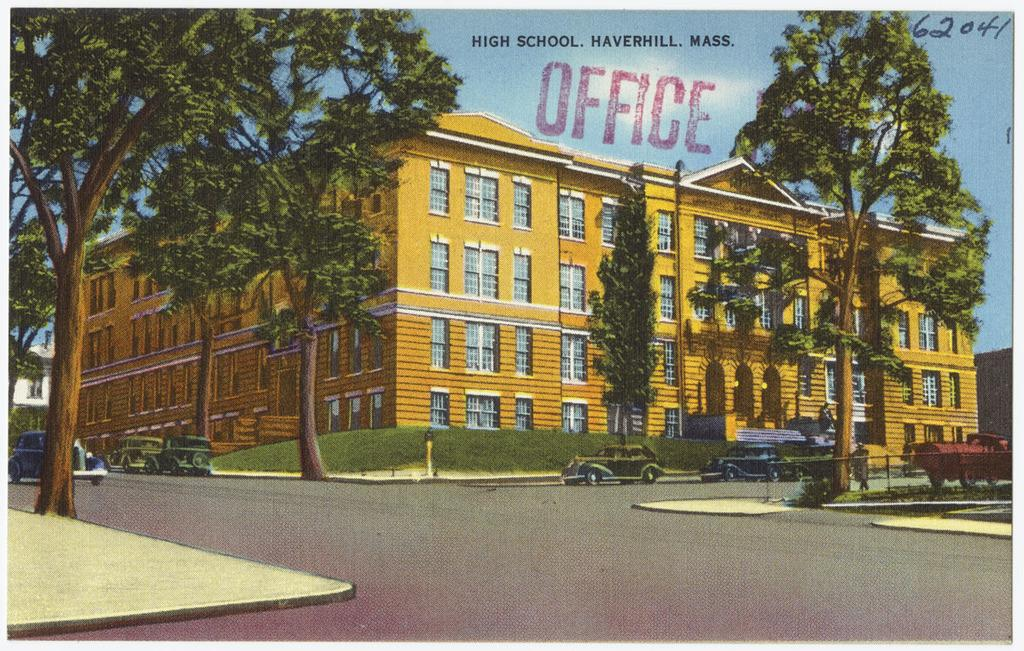What type of structure is visible in the image? There is a building with windows in the image. What else can be seen on the ground in the image? Vehicles are present on the road in the image. What natural elements are visible in the image? Trees are visible in the image. Can you describe any additional features of the image? There is a watermark at the top of the image. What grade does the building in the image receive for its architectural design? The image does not provide any information about the architectural design of the building, nor does it include any grading system. 